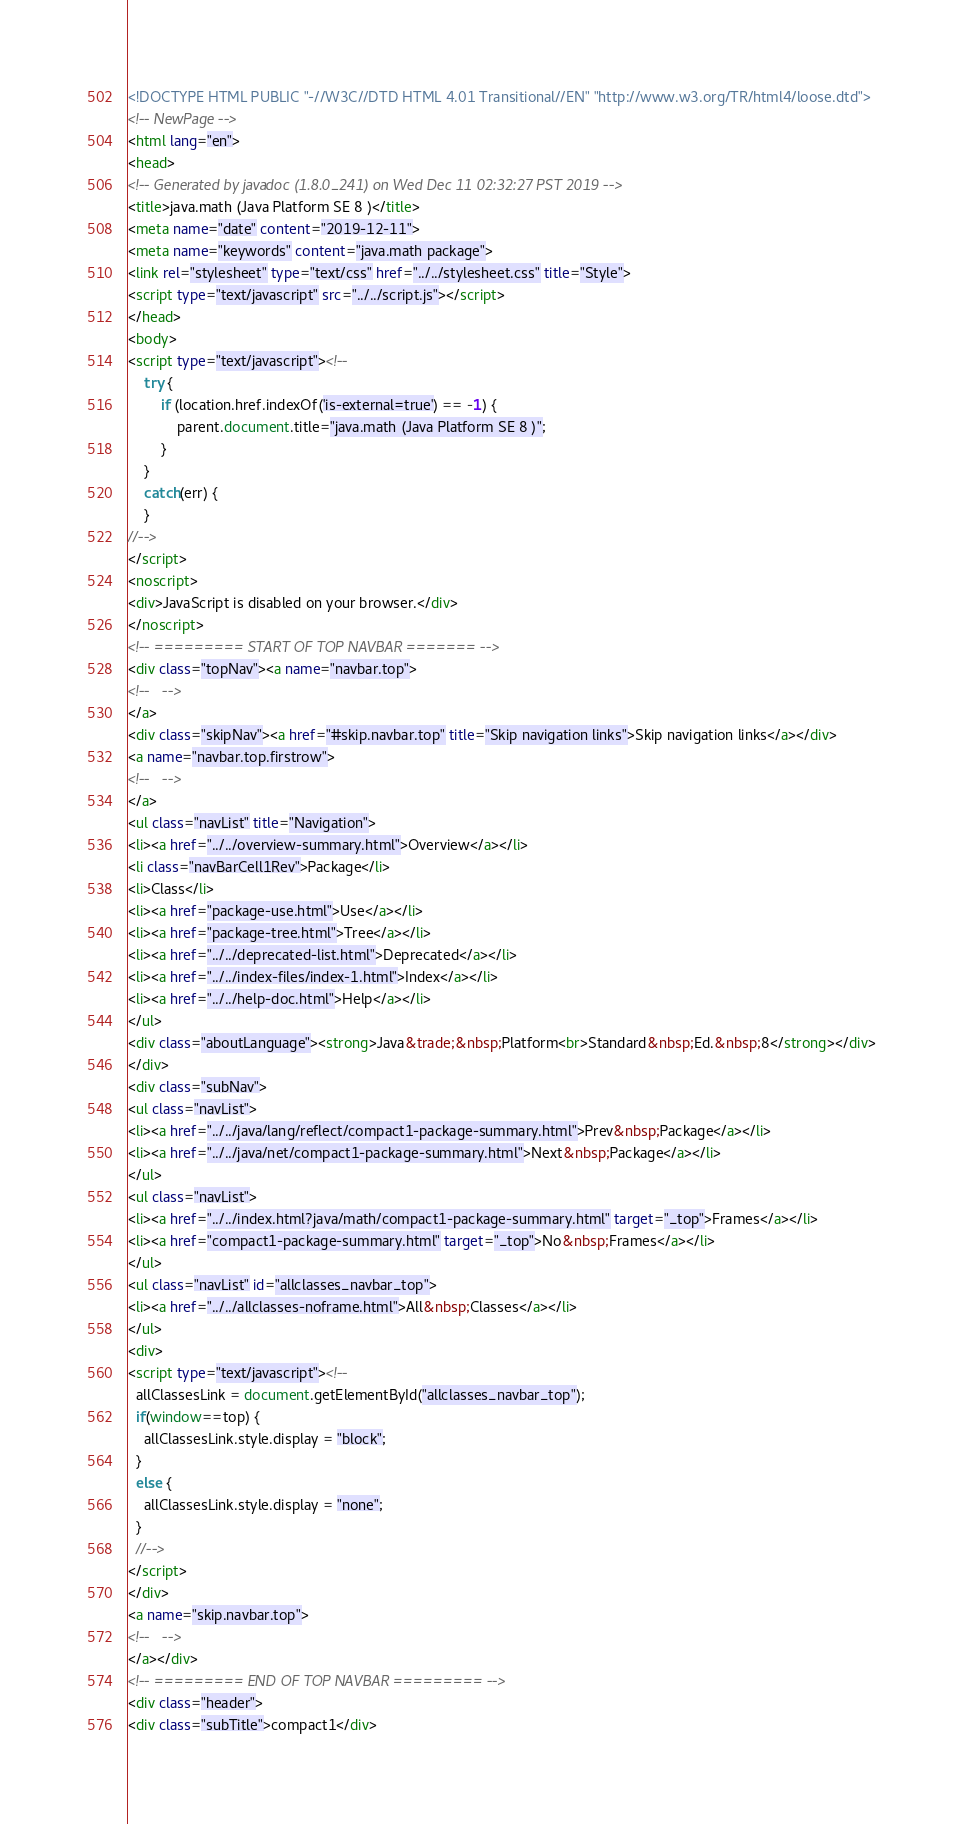Convert code to text. <code><loc_0><loc_0><loc_500><loc_500><_HTML_><!DOCTYPE HTML PUBLIC "-//W3C//DTD HTML 4.01 Transitional//EN" "http://www.w3.org/TR/html4/loose.dtd">
<!-- NewPage -->
<html lang="en">
<head>
<!-- Generated by javadoc (1.8.0_241) on Wed Dec 11 02:32:27 PST 2019 -->
<title>java.math (Java Platform SE 8 )</title>
<meta name="date" content="2019-12-11">
<meta name="keywords" content="java.math package">
<link rel="stylesheet" type="text/css" href="../../stylesheet.css" title="Style">
<script type="text/javascript" src="../../script.js"></script>
</head>
<body>
<script type="text/javascript"><!--
    try {
        if (location.href.indexOf('is-external=true') == -1) {
            parent.document.title="java.math (Java Platform SE 8 )";
        }
    }
    catch(err) {
    }
//-->
</script>
<noscript>
<div>JavaScript is disabled on your browser.</div>
</noscript>
<!-- ========= START OF TOP NAVBAR ======= -->
<div class="topNav"><a name="navbar.top">
<!--   -->
</a>
<div class="skipNav"><a href="#skip.navbar.top" title="Skip navigation links">Skip navigation links</a></div>
<a name="navbar.top.firstrow">
<!--   -->
</a>
<ul class="navList" title="Navigation">
<li><a href="../../overview-summary.html">Overview</a></li>
<li class="navBarCell1Rev">Package</li>
<li>Class</li>
<li><a href="package-use.html">Use</a></li>
<li><a href="package-tree.html">Tree</a></li>
<li><a href="../../deprecated-list.html">Deprecated</a></li>
<li><a href="../../index-files/index-1.html">Index</a></li>
<li><a href="../../help-doc.html">Help</a></li>
</ul>
<div class="aboutLanguage"><strong>Java&trade;&nbsp;Platform<br>Standard&nbsp;Ed.&nbsp;8</strong></div>
</div>
<div class="subNav">
<ul class="navList">
<li><a href="../../java/lang/reflect/compact1-package-summary.html">Prev&nbsp;Package</a></li>
<li><a href="../../java/net/compact1-package-summary.html">Next&nbsp;Package</a></li>
</ul>
<ul class="navList">
<li><a href="../../index.html?java/math/compact1-package-summary.html" target="_top">Frames</a></li>
<li><a href="compact1-package-summary.html" target="_top">No&nbsp;Frames</a></li>
</ul>
<ul class="navList" id="allclasses_navbar_top">
<li><a href="../../allclasses-noframe.html">All&nbsp;Classes</a></li>
</ul>
<div>
<script type="text/javascript"><!--
  allClassesLink = document.getElementById("allclasses_navbar_top");
  if(window==top) {
    allClassesLink.style.display = "block";
  }
  else {
    allClassesLink.style.display = "none";
  }
  //-->
</script>
</div>
<a name="skip.navbar.top">
<!--   -->
</a></div>
<!-- ========= END OF TOP NAVBAR ========= -->
<div class="header">
<div class="subTitle">compact1</div></code> 